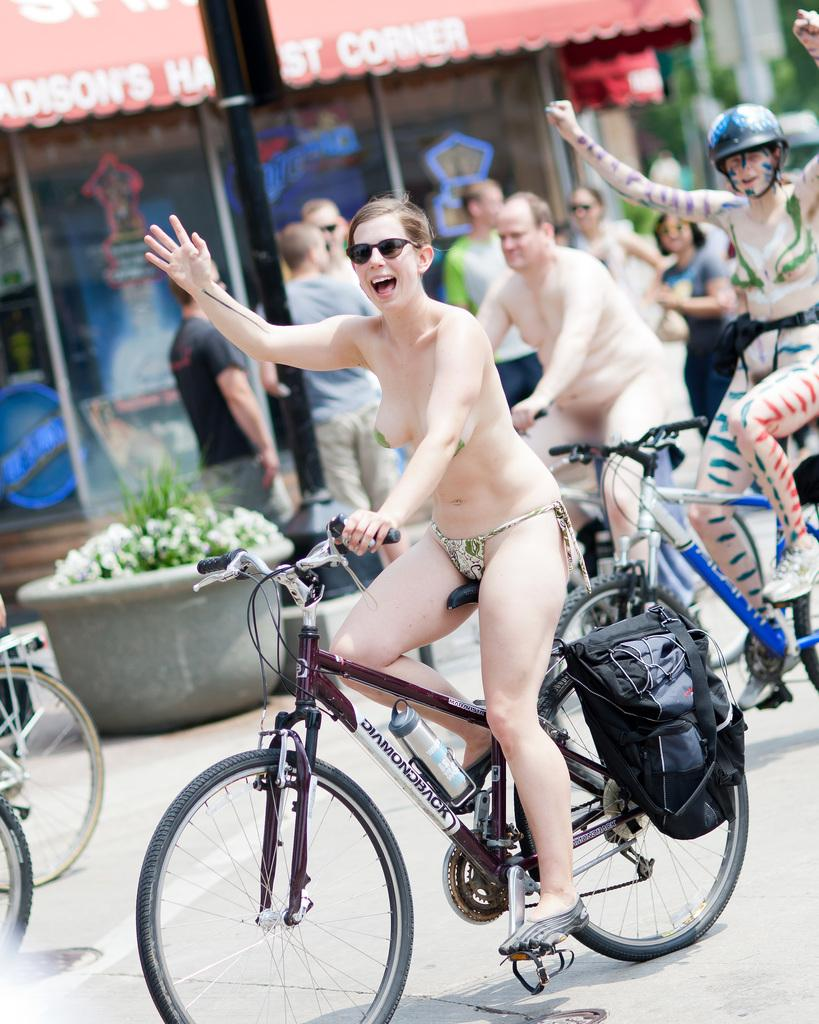What are the main subjects of the image? There are persons riding cycles in the image. What can be seen in the background of the image? There is a group of persons standing in the background of the image. What else is visible in the image besides the persons riding cycles and the group of persons standing? There are objects visible around the persons. What type of lunchroom can be seen in the image? There is no lunchroom present in the image. What is the position of the value in the image? There is no value mentioned or visible in the image. 